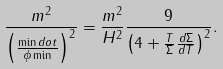Convert formula to latex. <formula><loc_0><loc_0><loc_500><loc_500>\frac { m ^ { 2 } } { \left ( \frac { \min d o t } { \phi \min } \right ) ^ { 2 } } & = \frac { m ^ { 2 } } { H ^ { 2 } } { \frac { 9 } { \left ( 4 + \frac { T } { \Sigma } \frac { d \Sigma } { d T } \right ) ^ { 2 } } } . \\</formula> 